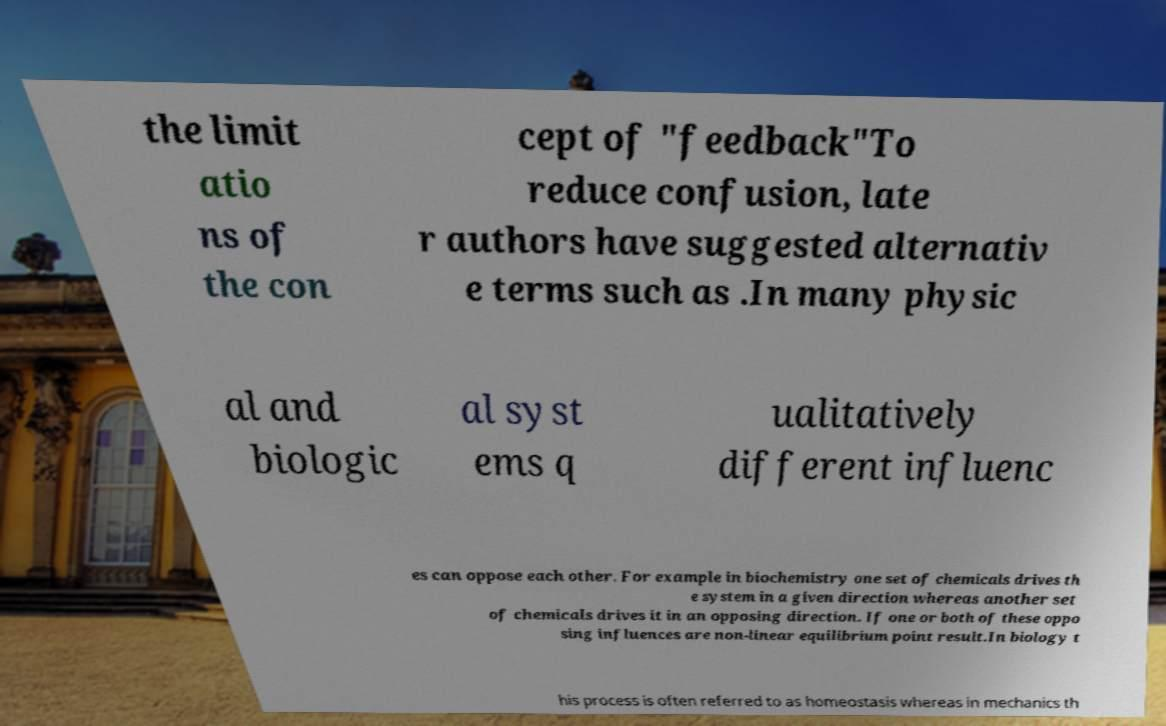What messages or text are displayed in this image? I need them in a readable, typed format. the limit atio ns of the con cept of "feedback"To reduce confusion, late r authors have suggested alternativ e terms such as .In many physic al and biologic al syst ems q ualitatively different influenc es can oppose each other. For example in biochemistry one set of chemicals drives th e system in a given direction whereas another set of chemicals drives it in an opposing direction. If one or both of these oppo sing influences are non-linear equilibrium point result.In biology t his process is often referred to as homeostasis whereas in mechanics th 